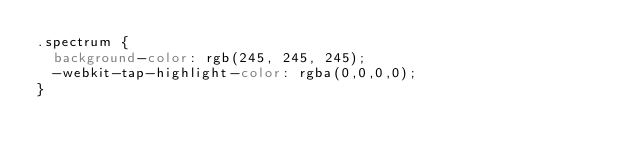Convert code to text. <code><loc_0><loc_0><loc_500><loc_500><_CSS_>.spectrum {
  background-color: rgb(245, 245, 245);
  -webkit-tap-highlight-color: rgba(0,0,0,0);
}
</code> 